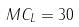Convert formula to latex. <formula><loc_0><loc_0><loc_500><loc_500>M C _ { L } = 3 0</formula> 